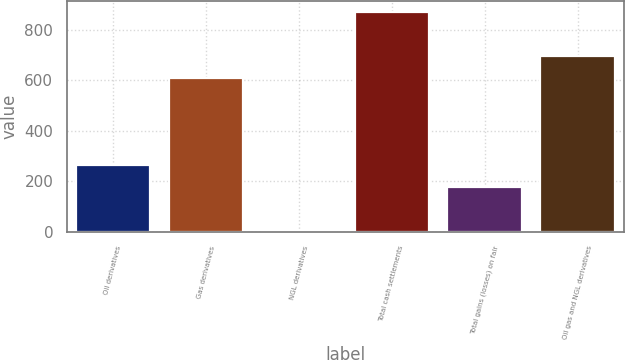<chart> <loc_0><loc_0><loc_500><loc_500><bar_chart><fcel>Oil derivatives<fcel>Gas derivatives<fcel>NGL derivatives<fcel>Total cash settlements<fcel>Total gains (losses) on fair<fcel>Oil gas and NGL derivatives<nl><fcel>263.9<fcel>610<fcel>1<fcel>870<fcel>177<fcel>696.9<nl></chart> 